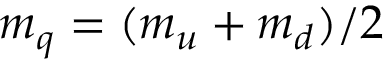<formula> <loc_0><loc_0><loc_500><loc_500>m _ { q } = ( m _ { u } + m _ { d } ) / 2</formula> 